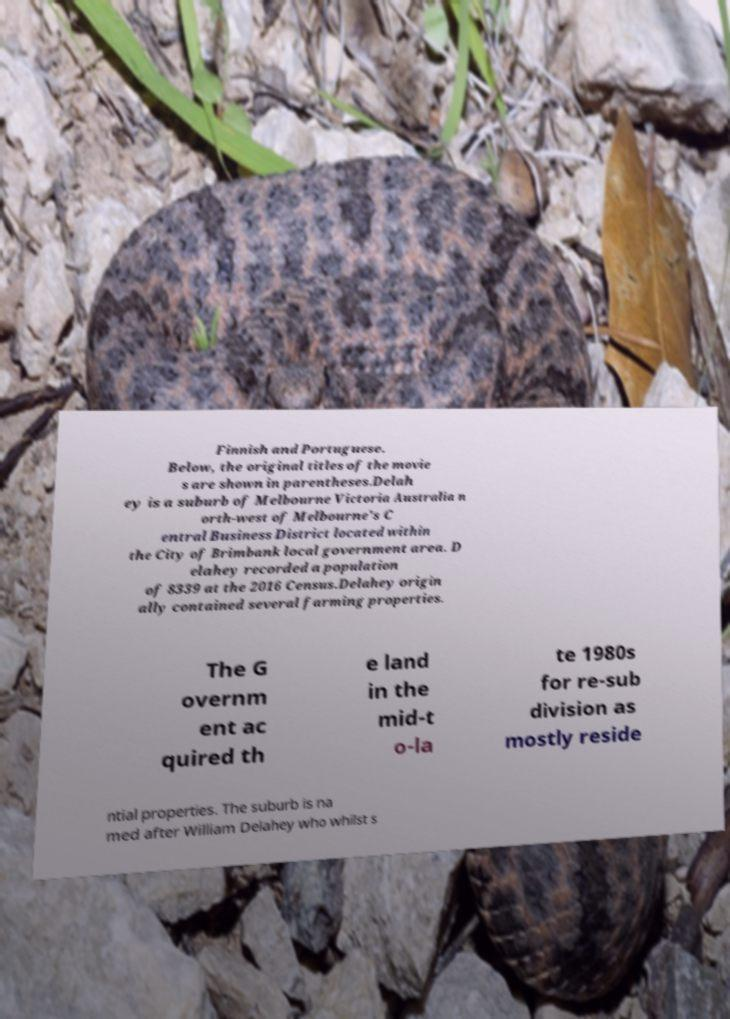Could you extract and type out the text from this image? Finnish and Portuguese. Below, the original titles of the movie s are shown in parentheses.Delah ey is a suburb of Melbourne Victoria Australia n orth-west of Melbourne's C entral Business District located within the City of Brimbank local government area. D elahey recorded a population of 8339 at the 2016 Census.Delahey origin ally contained several farming properties. The G overnm ent ac quired th e land in the mid-t o-la te 1980s for re-sub division as mostly reside ntial properties. The suburb is na med after William Delahey who whilst s 